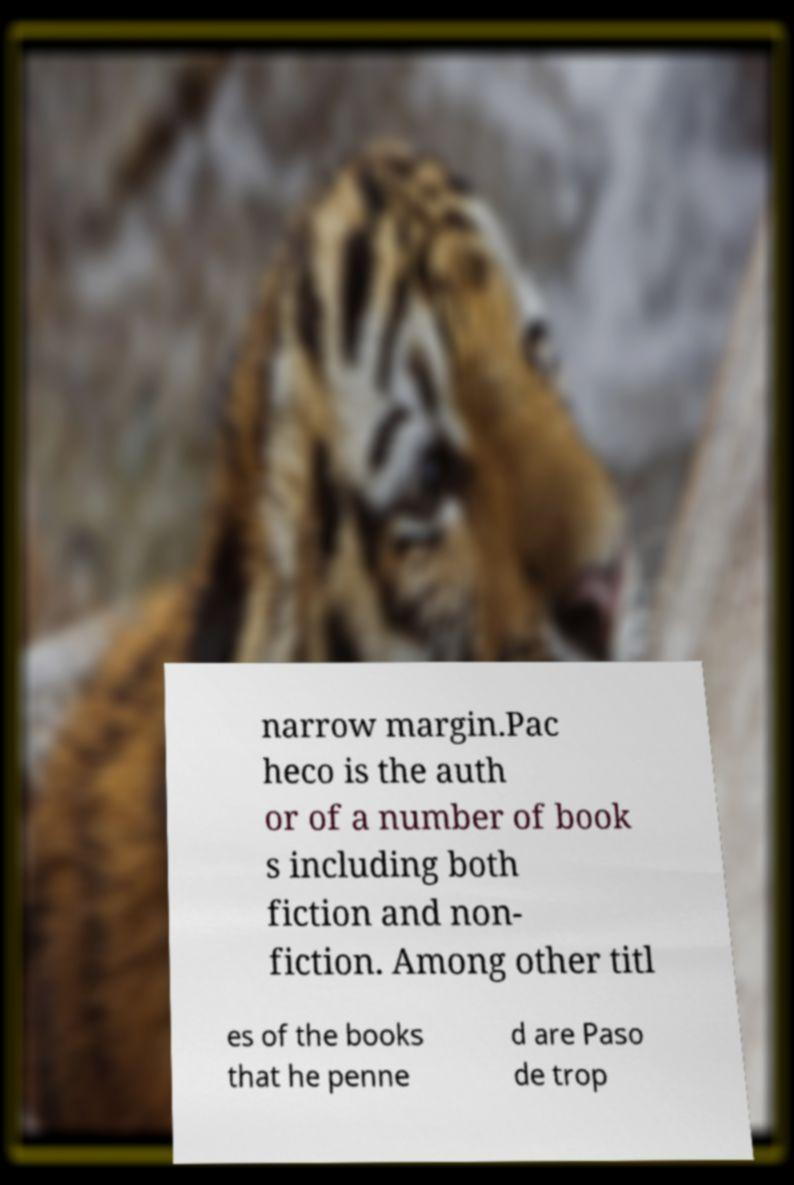Could you extract and type out the text from this image? narrow margin.Pac heco is the auth or of a number of book s including both fiction and non- fiction. Among other titl es of the books that he penne d are Paso de trop 